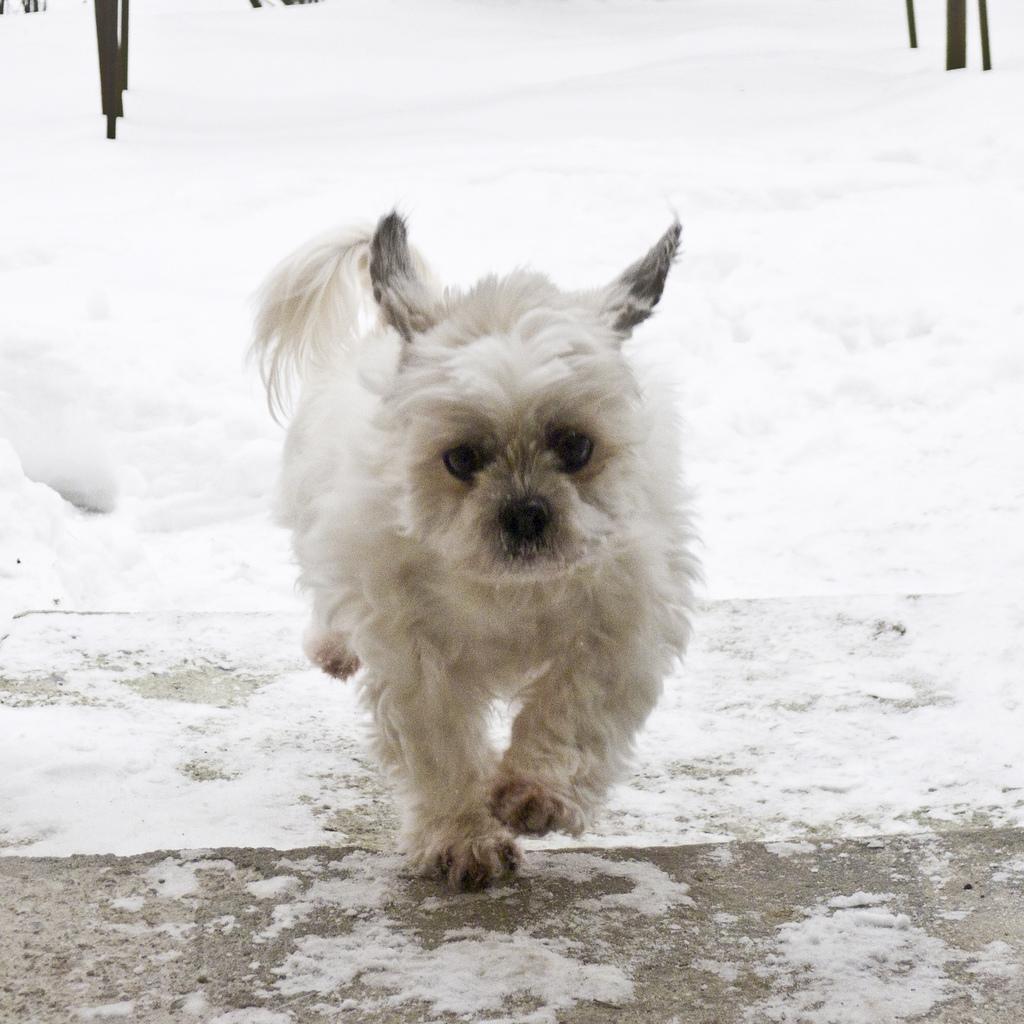Describe this image in one or two sentences. In this picture we can see an animal on the ground, snow and in the background we can see some objects. 